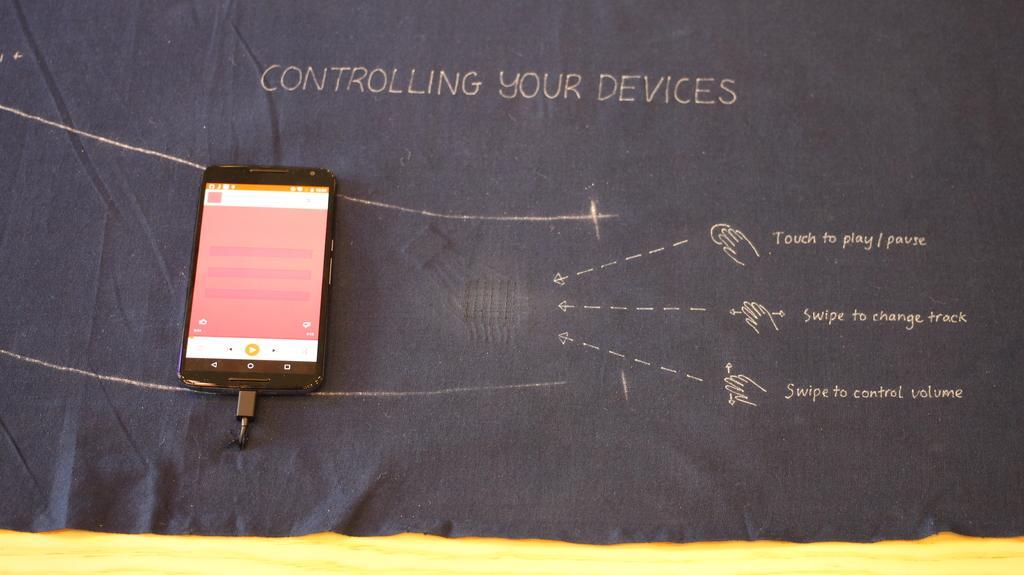<image>
Describe the image concisely. A phone sits on a piece of fabric with the words Controlling Your Devices written at the top. 